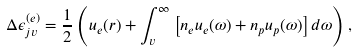<formula> <loc_0><loc_0><loc_500><loc_500>\Delta \epsilon _ { j v } ^ { ( e ) } = \frac { 1 } { 2 } \left ( u _ { e } ( r ) + \int _ { v } ^ { \infty } \left [ n _ { e } u _ { e } ( \omega ) + n _ { p } u _ { p } ( \omega ) \right ] d \omega \right ) ,</formula> 